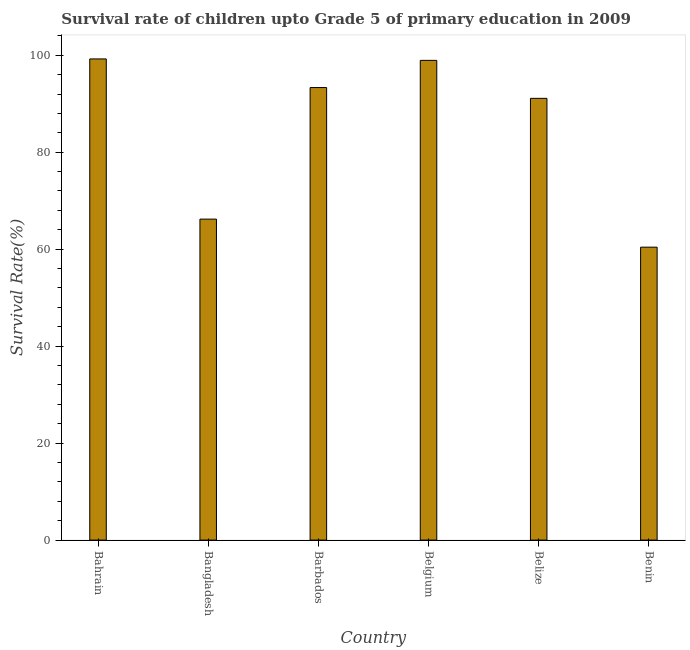Does the graph contain any zero values?
Offer a terse response. No. What is the title of the graph?
Give a very brief answer. Survival rate of children upto Grade 5 of primary education in 2009 . What is the label or title of the Y-axis?
Offer a very short reply. Survival Rate(%). What is the survival rate in Bangladesh?
Provide a succinct answer. 66.2. Across all countries, what is the maximum survival rate?
Offer a very short reply. 99.24. Across all countries, what is the minimum survival rate?
Your answer should be very brief. 60.42. In which country was the survival rate maximum?
Your answer should be compact. Bahrain. In which country was the survival rate minimum?
Give a very brief answer. Benin. What is the sum of the survival rate?
Offer a terse response. 509.23. What is the difference between the survival rate in Bangladesh and Benin?
Ensure brevity in your answer.  5.79. What is the average survival rate per country?
Provide a short and direct response. 84.87. What is the median survival rate?
Keep it short and to the point. 92.22. In how many countries, is the survival rate greater than 24 %?
Keep it short and to the point. 6. What is the ratio of the survival rate in Bahrain to that in Belize?
Give a very brief answer. 1.09. Is the survival rate in Barbados less than that in Belize?
Offer a terse response. No. What is the difference between the highest and the second highest survival rate?
Your response must be concise. 0.29. Is the sum of the survival rate in Barbados and Belgium greater than the maximum survival rate across all countries?
Your response must be concise. Yes. What is the difference between the highest and the lowest survival rate?
Provide a short and direct response. 38.82. What is the difference between two consecutive major ticks on the Y-axis?
Provide a succinct answer. 20. What is the Survival Rate(%) of Bahrain?
Provide a succinct answer. 99.24. What is the Survival Rate(%) of Bangladesh?
Make the answer very short. 66.2. What is the Survival Rate(%) of Barbados?
Provide a short and direct response. 93.33. What is the Survival Rate(%) in Belgium?
Your answer should be very brief. 98.94. What is the Survival Rate(%) of Belize?
Your answer should be very brief. 91.11. What is the Survival Rate(%) in Benin?
Make the answer very short. 60.42. What is the difference between the Survival Rate(%) in Bahrain and Bangladesh?
Your response must be concise. 33.03. What is the difference between the Survival Rate(%) in Bahrain and Barbados?
Offer a terse response. 5.9. What is the difference between the Survival Rate(%) in Bahrain and Belgium?
Your answer should be compact. 0.29. What is the difference between the Survival Rate(%) in Bahrain and Belize?
Keep it short and to the point. 8.13. What is the difference between the Survival Rate(%) in Bahrain and Benin?
Offer a terse response. 38.82. What is the difference between the Survival Rate(%) in Bangladesh and Barbados?
Provide a short and direct response. -27.13. What is the difference between the Survival Rate(%) in Bangladesh and Belgium?
Keep it short and to the point. -32.74. What is the difference between the Survival Rate(%) in Bangladesh and Belize?
Make the answer very short. -24.9. What is the difference between the Survival Rate(%) in Bangladesh and Benin?
Your response must be concise. 5.79. What is the difference between the Survival Rate(%) in Barbados and Belgium?
Provide a short and direct response. -5.61. What is the difference between the Survival Rate(%) in Barbados and Belize?
Provide a short and direct response. 2.23. What is the difference between the Survival Rate(%) in Barbados and Benin?
Provide a succinct answer. 32.92. What is the difference between the Survival Rate(%) in Belgium and Belize?
Provide a succinct answer. 7.84. What is the difference between the Survival Rate(%) in Belgium and Benin?
Give a very brief answer. 38.53. What is the difference between the Survival Rate(%) in Belize and Benin?
Give a very brief answer. 30.69. What is the ratio of the Survival Rate(%) in Bahrain to that in Bangladesh?
Offer a terse response. 1.5. What is the ratio of the Survival Rate(%) in Bahrain to that in Barbados?
Offer a terse response. 1.06. What is the ratio of the Survival Rate(%) in Bahrain to that in Belgium?
Ensure brevity in your answer.  1. What is the ratio of the Survival Rate(%) in Bahrain to that in Belize?
Offer a very short reply. 1.09. What is the ratio of the Survival Rate(%) in Bahrain to that in Benin?
Your response must be concise. 1.64. What is the ratio of the Survival Rate(%) in Bangladesh to that in Barbados?
Your response must be concise. 0.71. What is the ratio of the Survival Rate(%) in Bangladesh to that in Belgium?
Provide a succinct answer. 0.67. What is the ratio of the Survival Rate(%) in Bangladesh to that in Belize?
Keep it short and to the point. 0.73. What is the ratio of the Survival Rate(%) in Bangladesh to that in Benin?
Offer a terse response. 1.1. What is the ratio of the Survival Rate(%) in Barbados to that in Belgium?
Your answer should be very brief. 0.94. What is the ratio of the Survival Rate(%) in Barbados to that in Benin?
Provide a succinct answer. 1.54. What is the ratio of the Survival Rate(%) in Belgium to that in Belize?
Offer a very short reply. 1.09. What is the ratio of the Survival Rate(%) in Belgium to that in Benin?
Your answer should be compact. 1.64. What is the ratio of the Survival Rate(%) in Belize to that in Benin?
Offer a terse response. 1.51. 